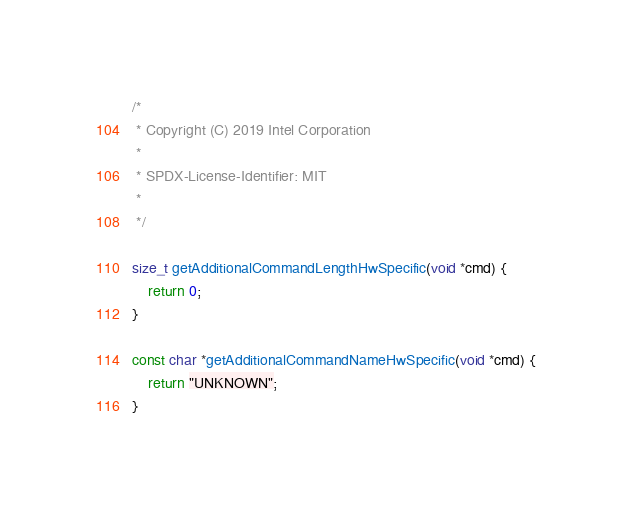<code> <loc_0><loc_0><loc_500><loc_500><_C++_>/*
 * Copyright (C) 2019 Intel Corporation
 *
 * SPDX-License-Identifier: MIT
 *
 */

size_t getAdditionalCommandLengthHwSpecific(void *cmd) {
    return 0;
}

const char *getAdditionalCommandNameHwSpecific(void *cmd) {
    return "UNKNOWN";
}
</code> 